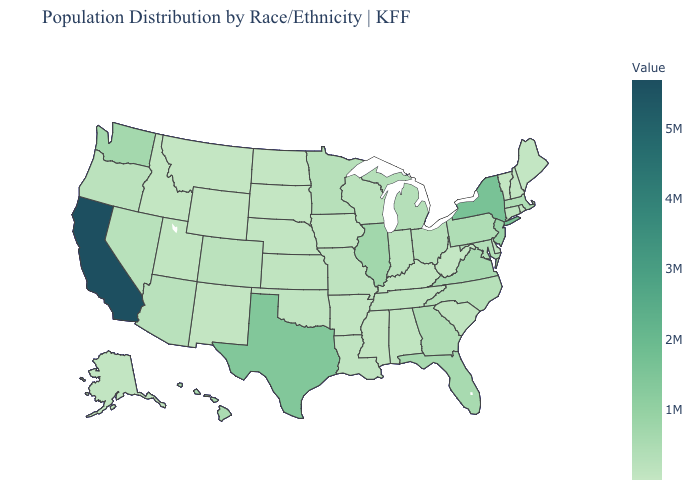Does the map have missing data?
Write a very short answer. No. Which states have the lowest value in the USA?
Be succinct. Wyoming. Among the states that border West Virginia , which have the lowest value?
Be succinct. Kentucky. Among the states that border Mississippi , which have the lowest value?
Give a very brief answer. Arkansas. Does Georgia have the highest value in the USA?
Quick response, please. No. 